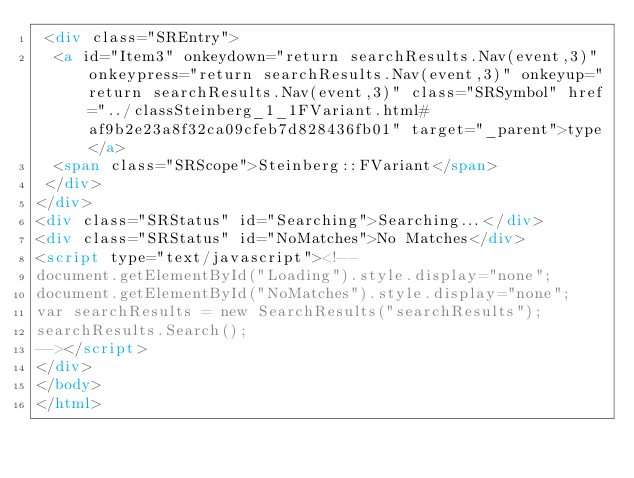<code> <loc_0><loc_0><loc_500><loc_500><_HTML_> <div class="SREntry">
  <a id="Item3" onkeydown="return searchResults.Nav(event,3)" onkeypress="return searchResults.Nav(event,3)" onkeyup="return searchResults.Nav(event,3)" class="SRSymbol" href="../classSteinberg_1_1FVariant.html#af9b2e23a8f32ca09cfeb7d828436fb01" target="_parent">type</a>
  <span class="SRScope">Steinberg::FVariant</span>
 </div>
</div>
<div class="SRStatus" id="Searching">Searching...</div>
<div class="SRStatus" id="NoMatches">No Matches</div>
<script type="text/javascript"><!--
document.getElementById("Loading").style.display="none";
document.getElementById("NoMatches").style.display="none";
var searchResults = new SearchResults("searchResults");
searchResults.Search();
--></script>
</div>
</body>
</html>
</code> 